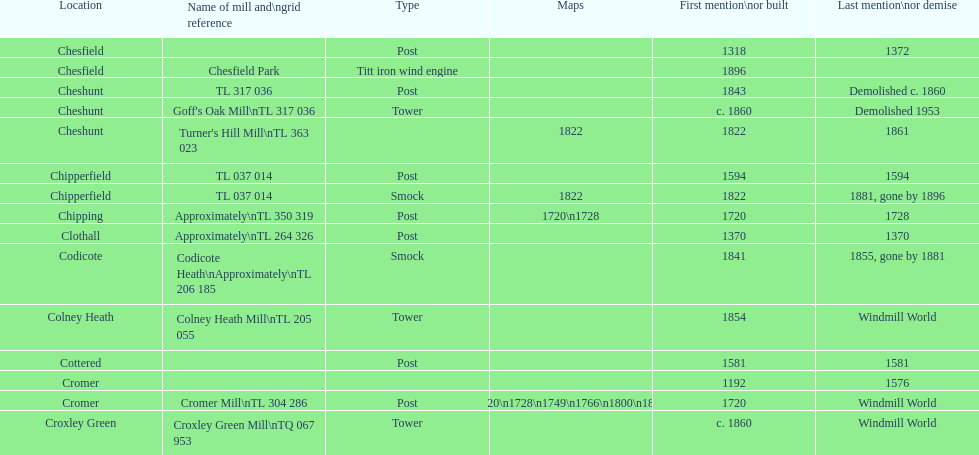What is the sole "c" mill called in colney health? Colney Heath Mill. 